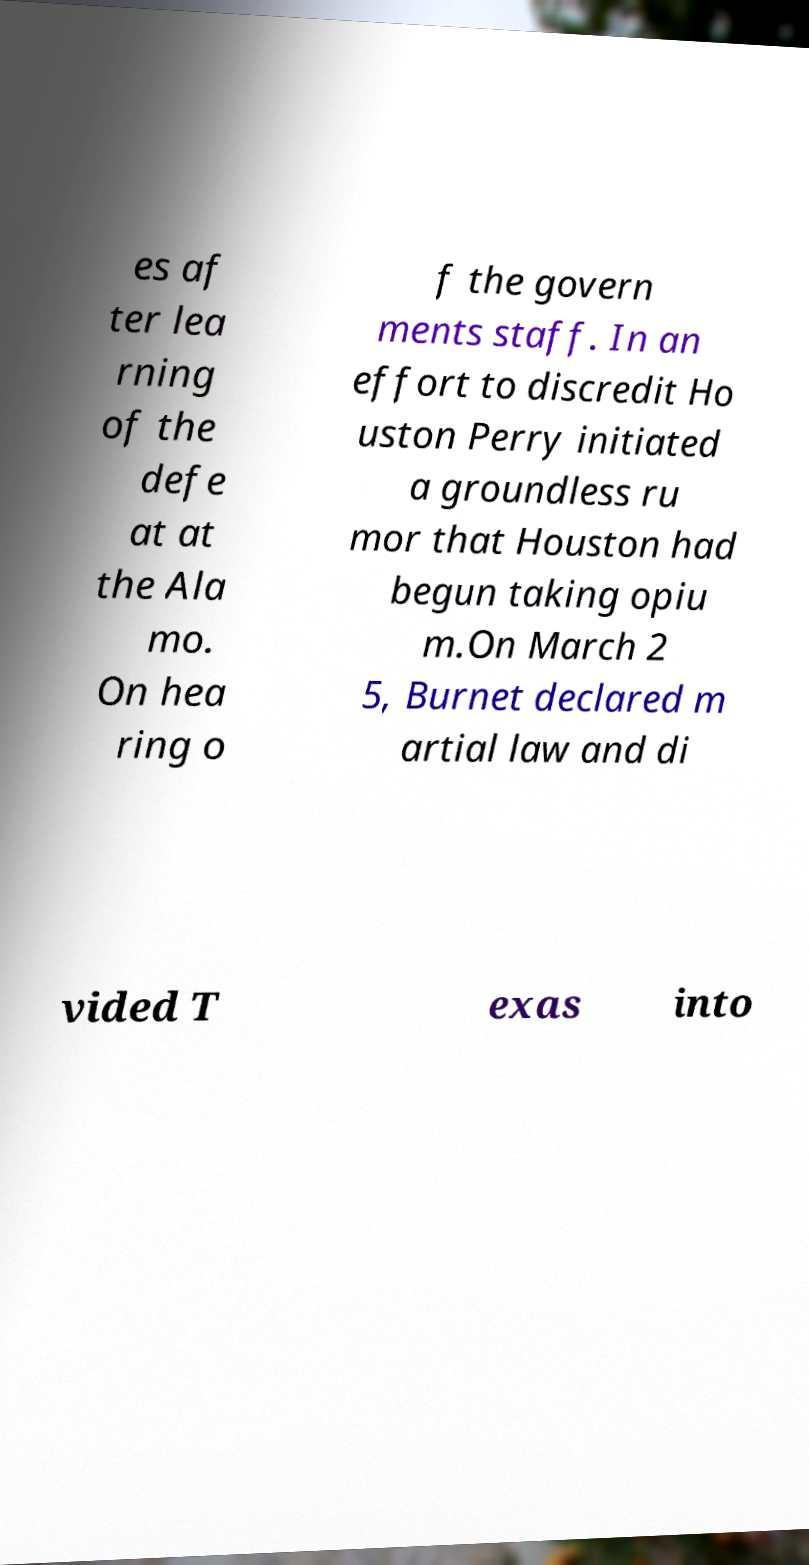There's text embedded in this image that I need extracted. Can you transcribe it verbatim? es af ter lea rning of the defe at at the Ala mo. On hea ring o f the govern ments staff. In an effort to discredit Ho uston Perry initiated a groundless ru mor that Houston had begun taking opiu m.On March 2 5, Burnet declared m artial law and di vided T exas into 